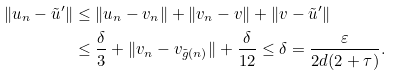<formula> <loc_0><loc_0><loc_500><loc_500>\| u _ { n } - \tilde { u } ^ { \prime } \| & \leq \| u _ { n } - v _ { n } \| + \| v _ { n } - v \| + \| v - \tilde { u } ^ { \prime } \| \\ & \leq \frac { \delta } { 3 } + \| v _ { n } - v _ { \tilde { g } ( n ) } \| + \frac { \delta } { 1 2 } \leq \delta = \frac { \varepsilon } { 2 d ( 2 + \tau ) } .</formula> 